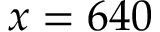<formula> <loc_0><loc_0><loc_500><loc_500>x = 6 4 0</formula> 